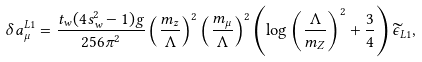Convert formula to latex. <formula><loc_0><loc_0><loc_500><loc_500>\delta a _ { \mu } ^ { L 1 } = \frac { t _ { w } ( 4 s _ { w } ^ { 2 } - 1 ) g } { 2 5 6 \pi ^ { 2 } } \left ( \frac { m _ { z } } { \Lambda } \right ) ^ { 2 } \left ( \frac { m _ { \mu } } { \Lambda } \right ) ^ { 2 } \left ( \log \left ( \frac { \Lambda } { m _ { Z } } \right ) ^ { 2 } + \frac { 3 } { 4 } \right ) \widetilde { \epsilon } _ { L 1 } ,</formula> 